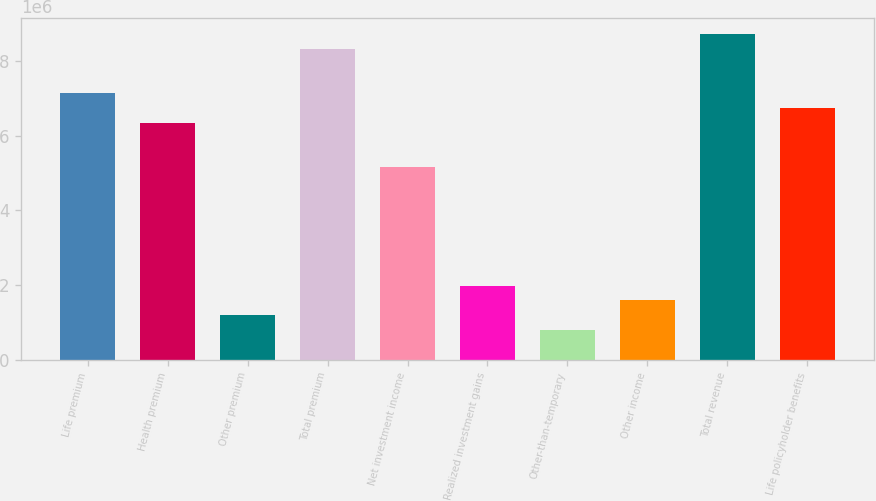Convert chart to OTSL. <chart><loc_0><loc_0><loc_500><loc_500><bar_chart><fcel>Life premium<fcel>Health premium<fcel>Other premium<fcel>Total premium<fcel>Net investment income<fcel>Realized investment gains<fcel>Other-than-temporary<fcel>Other income<fcel>Total revenue<fcel>Life policyholder benefits<nl><fcel>7.13573e+06<fcel>6.34287e+06<fcel>1.18929e+06<fcel>8.32502e+06<fcel>5.15358e+06<fcel>1.98215e+06<fcel>792862<fcel>1.58572e+06<fcel>8.72145e+06<fcel>6.7393e+06<nl></chart> 